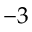Convert formula to latex. <formula><loc_0><loc_0><loc_500><loc_500>- 3</formula> 